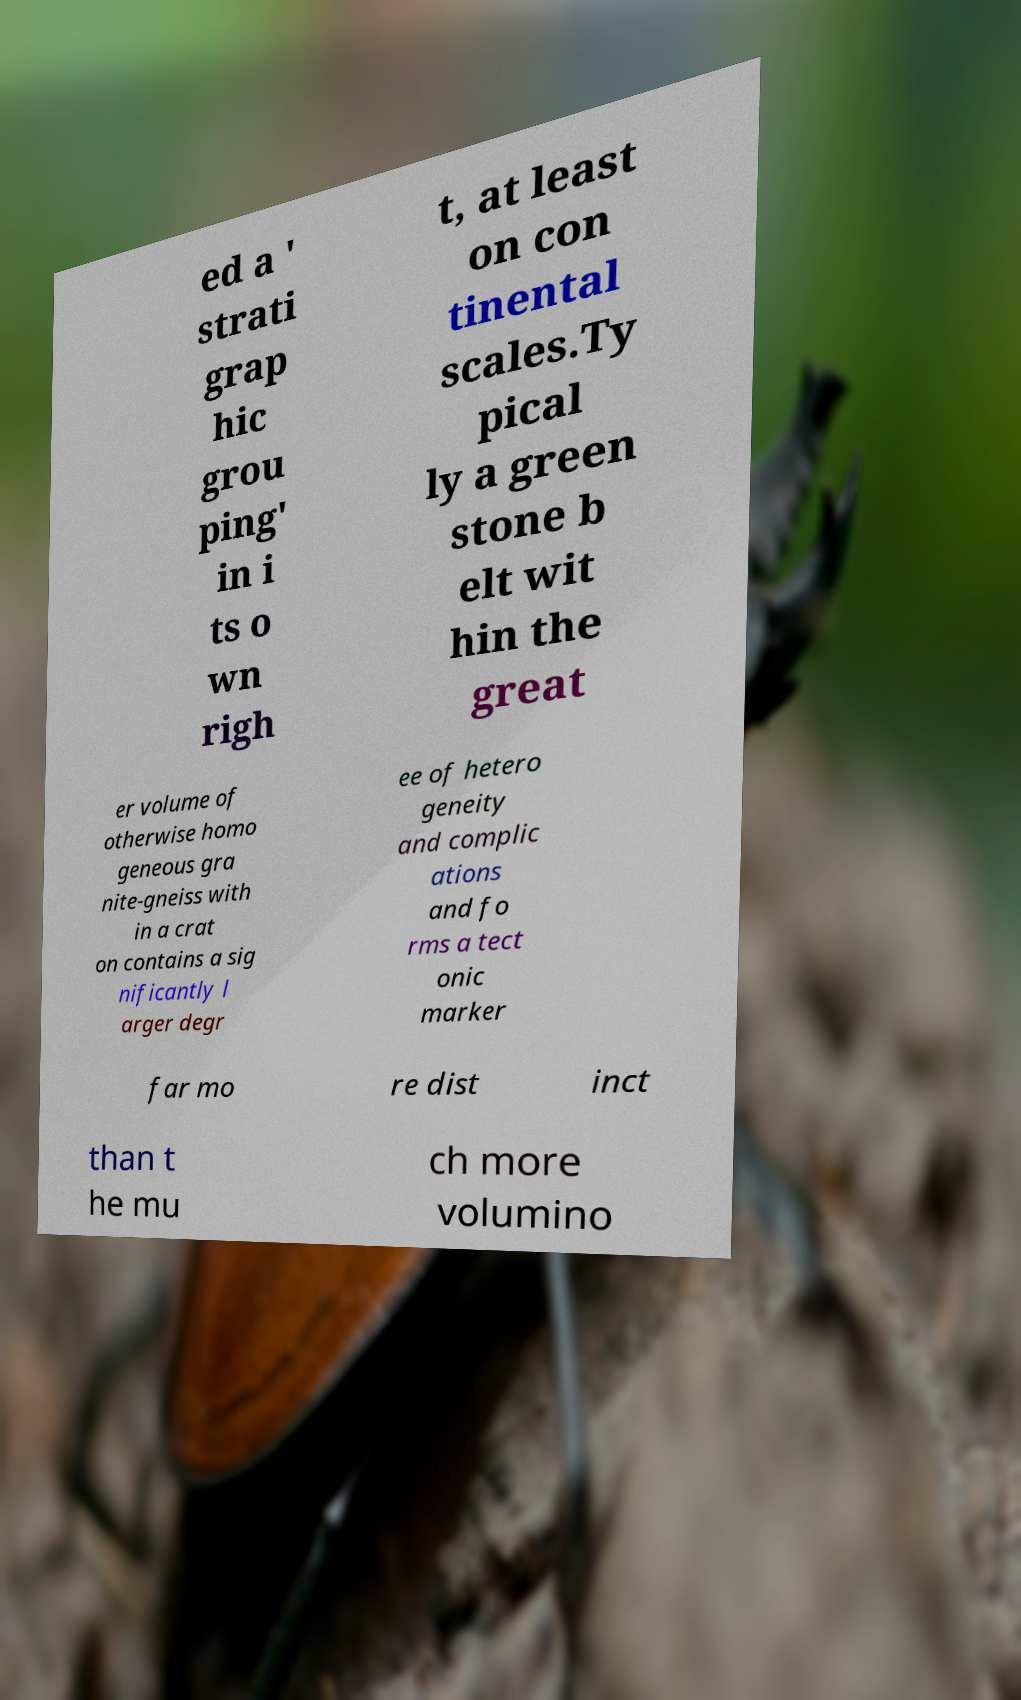Could you assist in decoding the text presented in this image and type it out clearly? ed a ' strati grap hic grou ping' in i ts o wn righ t, at least on con tinental scales.Ty pical ly a green stone b elt wit hin the great er volume of otherwise homo geneous gra nite-gneiss with in a crat on contains a sig nificantly l arger degr ee of hetero geneity and complic ations and fo rms a tect onic marker far mo re dist inct than t he mu ch more volumino 